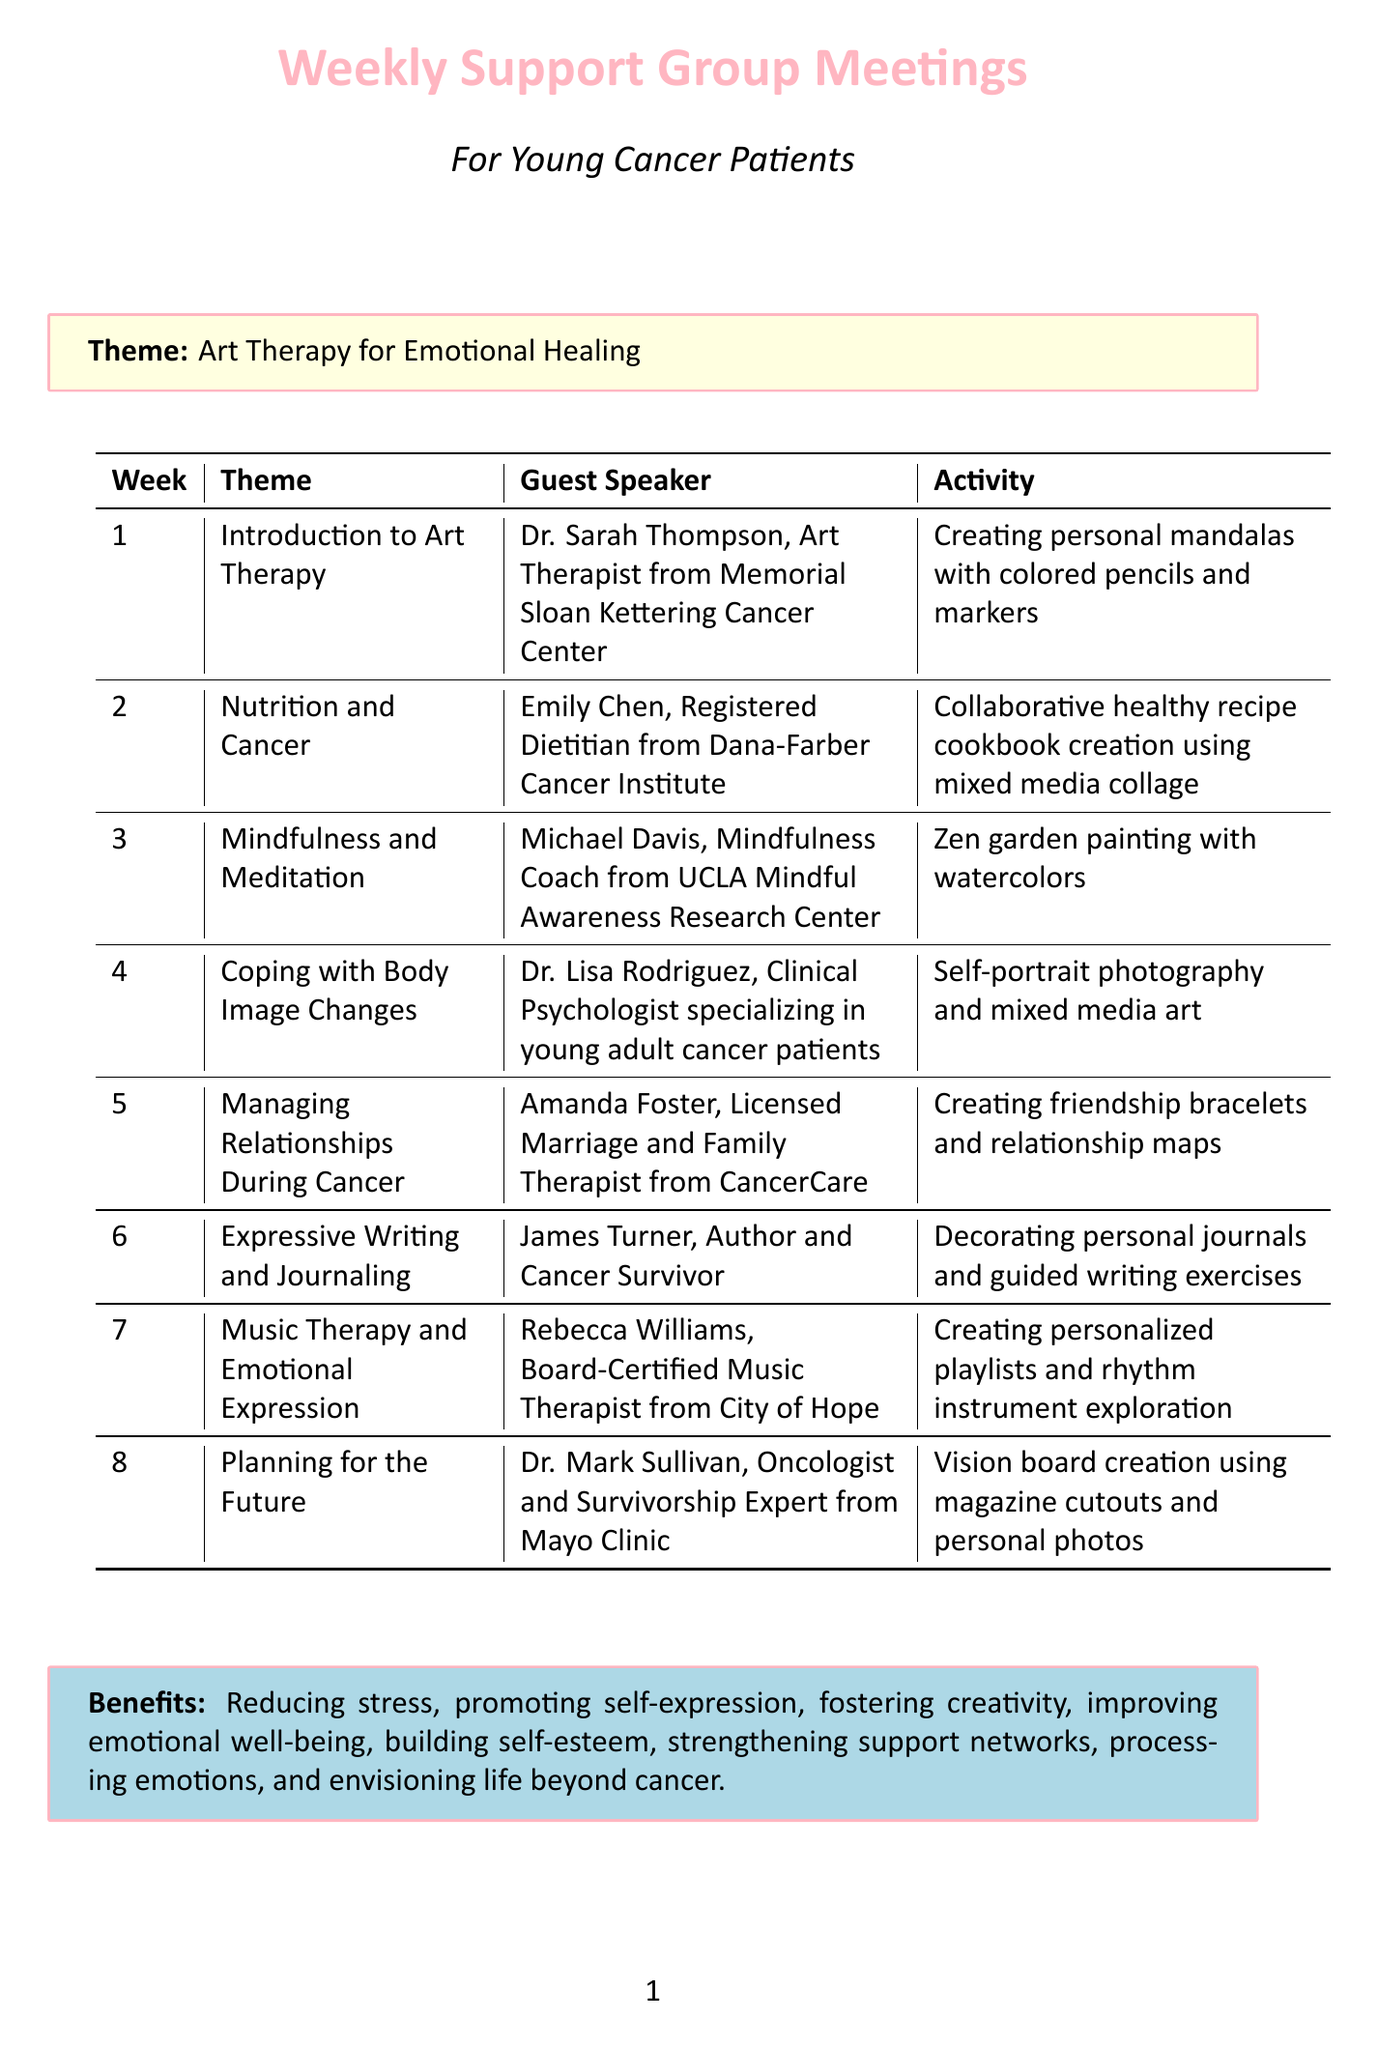What is the theme of Week 1? The theme for Week 1 is the first listed theme in the document, which is "Introduction to Art Therapy."
Answer: Introduction to Art Therapy Who is the guest speaker for Week 4? The guest speaker for Week 4 is the medical expert mentioned in the document for that week, which is "Dr. Lisa Rodriguez."
Answer: Dr. Lisa Rodriguez What activity is planned for Week 6? The activity planned for Week 6 is described specifically in the document as an artistic endeavor, which is "Decorating personal journals and guided writing exercises."
Answer: Decorating personal journals and guided writing exercises How many weeks are included in the support group meetings? There are eight meetings as enumerated in the document, with a count of listed weeks in the schedule.
Answer: 8 What type of art activity will take place in Week 5? The art activity for Week 5 is included as a creative project in the document, specifically described as "Creating friendship bracelets and relationship maps."
Answer: Creating friendship bracelets and relationship maps Which week focuses on mindfulness? The week that highlights mindfulness as the theme is indicated as the third meeting in the document.
Answer: Week 3 What is the benefit associated with the activity in Week 7? The benefits associated with the activities are listed in the document; for Week 7, one of the benefits is "Mood enhancement."
Answer: Mood enhancement Who will lead the discussion on Nutrition and Cancer? The person leading the discussion is identified by their title and affiliation in the document as "Emily Chen."
Answer: Emily Chen 